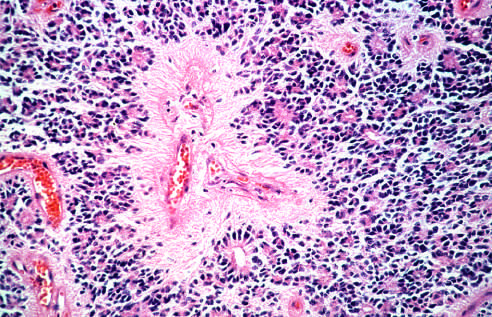do lymphoid aggregates with germinal centers and abundant subepi-thelial plasma cells within the superficial lamina propria have round nuclei, often with a clear cytoplasmic halo in oligodendroglioma?
Answer the question using a single word or phrase. No 